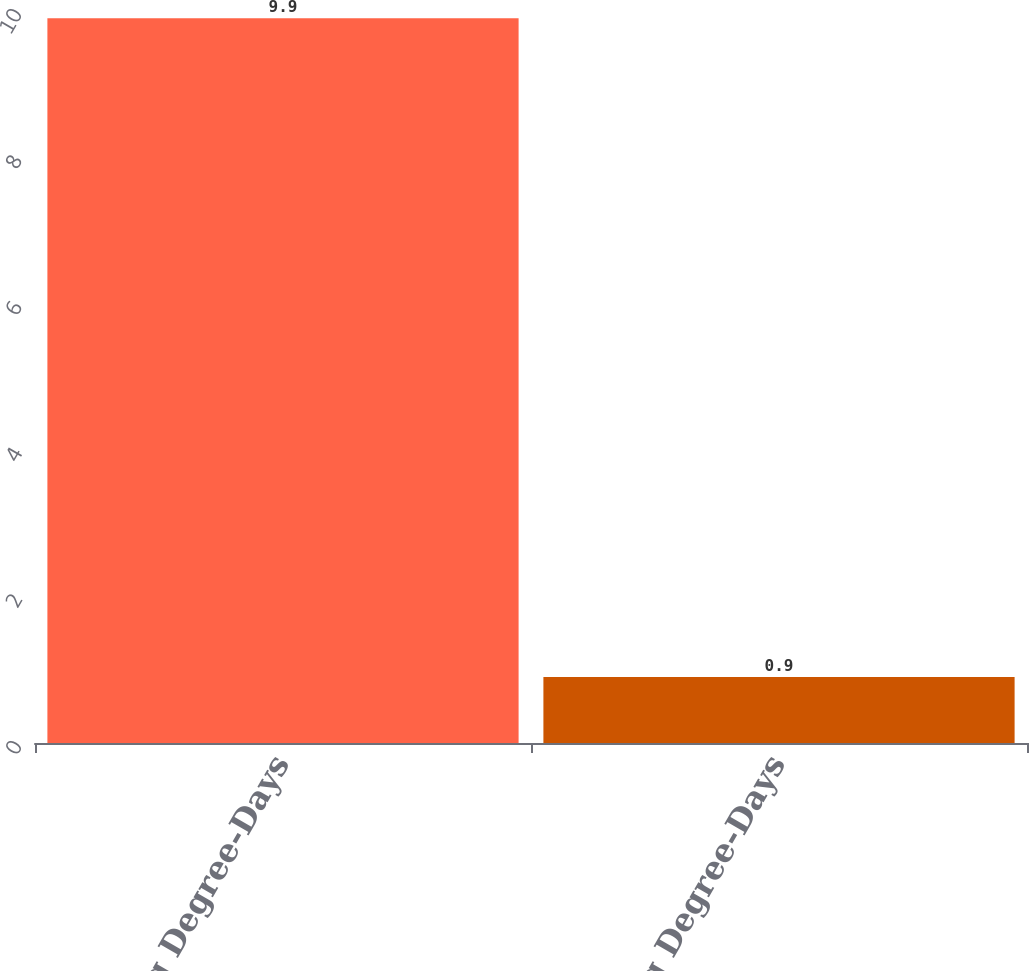<chart> <loc_0><loc_0><loc_500><loc_500><bar_chart><fcel>Heating Degree-Days<fcel>Cooling Degree-Days<nl><fcel>9.9<fcel>0.9<nl></chart> 